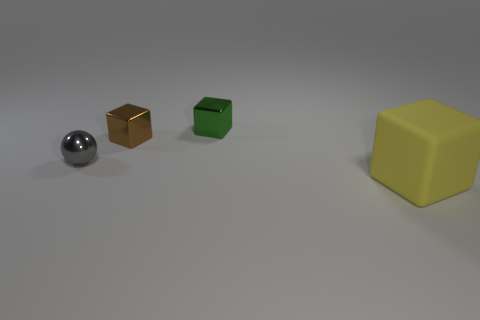Add 3 tiny brown cylinders. How many objects exist? 7 Subtract all yellow cubes. How many cubes are left? 2 Subtract all cubes. How many objects are left? 1 Subtract all yellow cubes. How many cubes are left? 2 Add 3 tiny metallic blocks. How many tiny metallic blocks are left? 5 Add 1 large yellow cubes. How many large yellow cubes exist? 2 Subtract 0 red balls. How many objects are left? 4 Subtract all purple blocks. Subtract all red spheres. How many blocks are left? 3 Subtract all green balls. How many cyan cubes are left? 0 Subtract all big gray metallic objects. Subtract all yellow blocks. How many objects are left? 3 